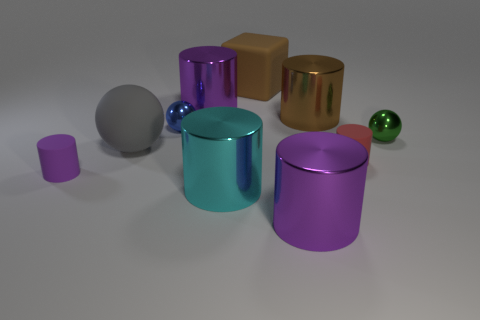How many purple cylinders must be subtracted to get 1 purple cylinders? 2 Subtract all red cylinders. How many cylinders are left? 5 Subtract all brown cylinders. How many cylinders are left? 5 Subtract all balls. How many objects are left? 7 Subtract 2 balls. How many balls are left? 1 Subtract 0 purple spheres. How many objects are left? 10 Subtract all red spheres. Subtract all yellow cylinders. How many spheres are left? 3 Subtract all cyan blocks. How many yellow balls are left? 0 Subtract all brown rubber things. Subtract all large red metal objects. How many objects are left? 9 Add 9 big brown matte cubes. How many big brown matte cubes are left? 10 